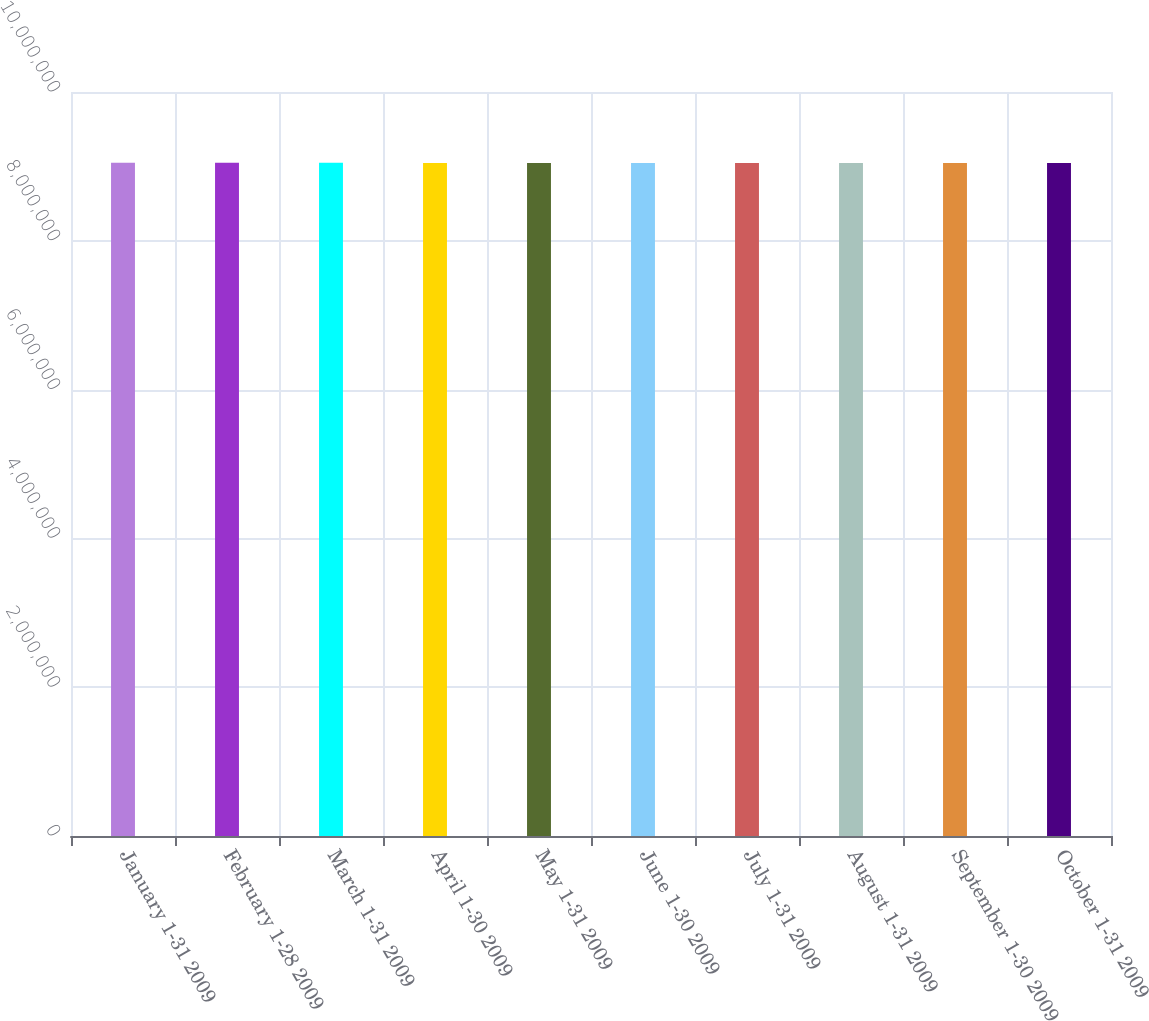Convert chart to OTSL. <chart><loc_0><loc_0><loc_500><loc_500><bar_chart><fcel>January 1-31 2009<fcel>February 1-28 2009<fcel>March 1-31 2009<fcel>April 1-30 2009<fcel>May 1-31 2009<fcel>June 1-30 2009<fcel>July 1-31 2009<fcel>August 1-31 2009<fcel>September 1-30 2009<fcel>October 1-31 2009<nl><fcel>9.04857e+06<fcel>9.04902e+06<fcel>9.04813e+06<fcel>9.0441e+06<fcel>9.04454e+06<fcel>9.04499e+06<fcel>9.04544e+06<fcel>9.04589e+06<fcel>9.04634e+06<fcel>9.04678e+06<nl></chart> 